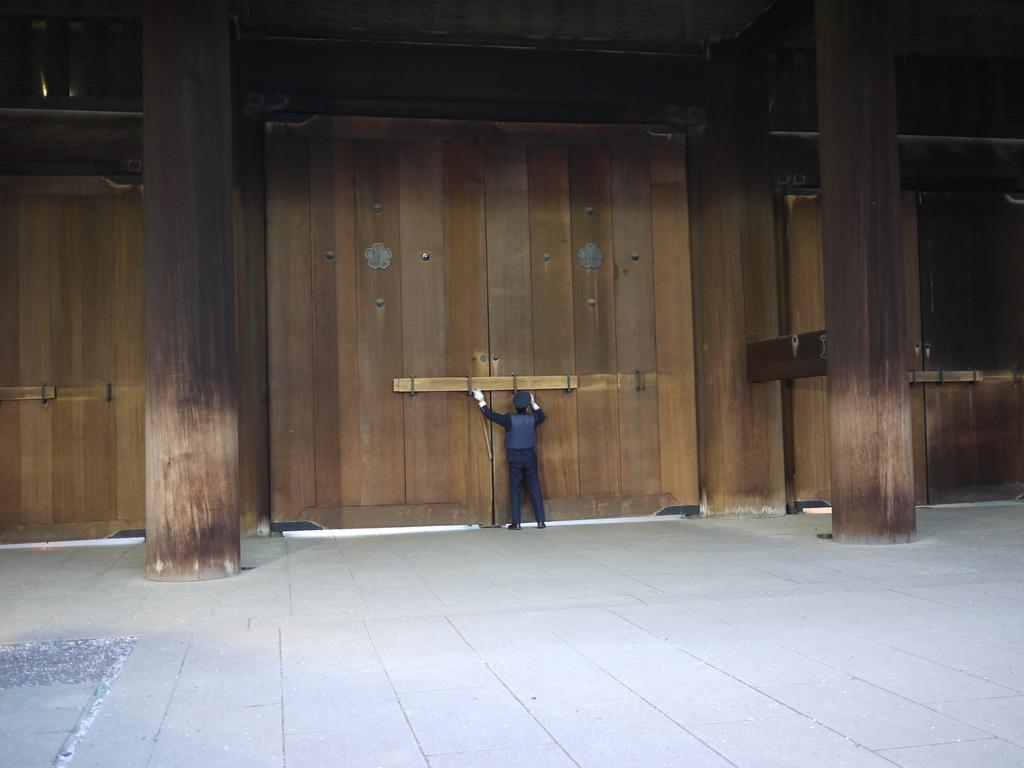Who is present in the image? There is a person in the image. What is the person wearing? The person is wearing a blue dress. What type of doors can be seen in the image? There are wooden doors in the image. What architectural feature is present in the image? There are wooden pillars in the image. What type of glass is used to make the bean in the image? There is no bean or glass present in the image. 